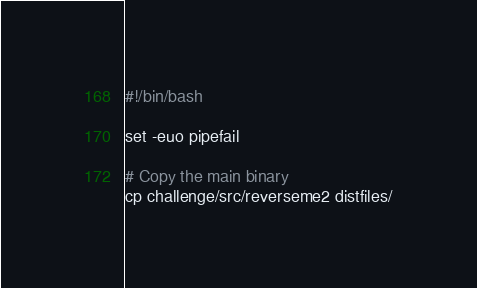<code> <loc_0><loc_0><loc_500><loc_500><_Bash_>#!/bin/bash

set -euo pipefail

# Copy the main binary
cp challenge/src/reverseme2 distfiles/
</code> 